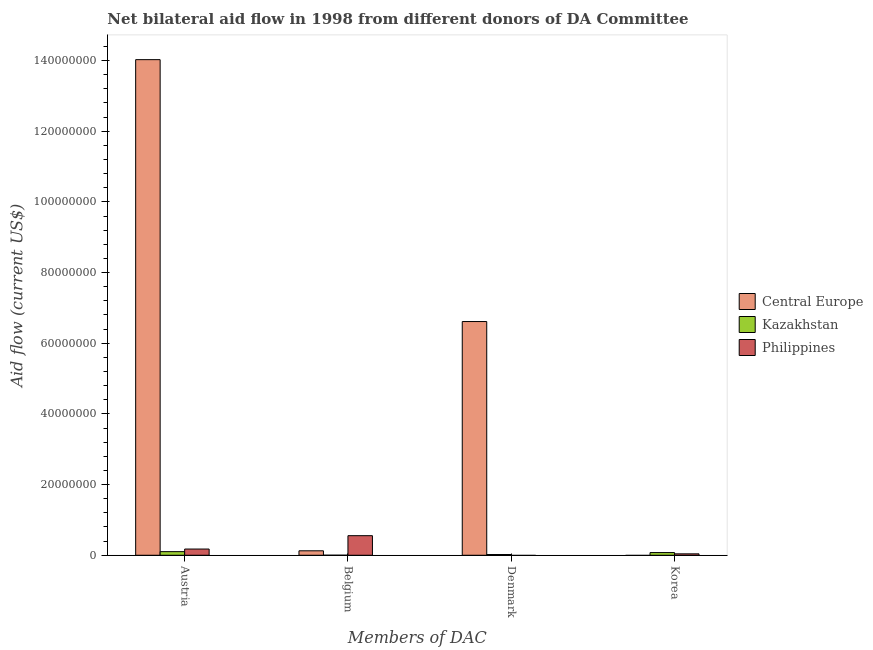How many different coloured bars are there?
Your answer should be compact. 3. How many bars are there on the 2nd tick from the left?
Offer a terse response. 3. How many bars are there on the 1st tick from the right?
Provide a succinct answer. 2. What is the label of the 4th group of bars from the left?
Your answer should be compact. Korea. What is the amount of aid given by austria in Kazakhstan?
Make the answer very short. 1.02e+06. Across all countries, what is the maximum amount of aid given by denmark?
Provide a succinct answer. 6.61e+07. Across all countries, what is the minimum amount of aid given by austria?
Make the answer very short. 1.02e+06. In which country was the amount of aid given by korea maximum?
Your answer should be very brief. Kazakhstan. What is the total amount of aid given by denmark in the graph?
Ensure brevity in your answer.  6.64e+07. What is the difference between the amount of aid given by belgium in Central Europe and that in Philippines?
Keep it short and to the point. -4.28e+06. What is the difference between the amount of aid given by denmark in Kazakhstan and the amount of aid given by austria in Central Europe?
Your answer should be very brief. -1.40e+08. What is the average amount of aid given by korea per country?
Offer a very short reply. 3.87e+05. What is the difference between the amount of aid given by austria and amount of aid given by belgium in Philippines?
Provide a succinct answer. -3.78e+06. What is the ratio of the amount of aid given by austria in Central Europe to that in Kazakhstan?
Give a very brief answer. 137.5. What is the difference between the highest and the second highest amount of aid given by belgium?
Offer a very short reply. 4.28e+06. What is the difference between the highest and the lowest amount of aid given by austria?
Your answer should be very brief. 1.39e+08. In how many countries, is the amount of aid given by austria greater than the average amount of aid given by austria taken over all countries?
Provide a succinct answer. 1. Is it the case that in every country, the sum of the amount of aid given by korea and amount of aid given by belgium is greater than the sum of amount of aid given by austria and amount of aid given by denmark?
Ensure brevity in your answer.  No. How many countries are there in the graph?
Your answer should be compact. 3. Does the graph contain grids?
Keep it short and to the point. No. How are the legend labels stacked?
Offer a very short reply. Vertical. What is the title of the graph?
Give a very brief answer. Net bilateral aid flow in 1998 from different donors of DA Committee. Does "China" appear as one of the legend labels in the graph?
Keep it short and to the point. No. What is the label or title of the X-axis?
Your answer should be compact. Members of DAC. What is the label or title of the Y-axis?
Your answer should be very brief. Aid flow (current US$). What is the Aid flow (current US$) of Central Europe in Austria?
Your response must be concise. 1.40e+08. What is the Aid flow (current US$) of Kazakhstan in Austria?
Provide a short and direct response. 1.02e+06. What is the Aid flow (current US$) in Philippines in Austria?
Your answer should be compact. 1.76e+06. What is the Aid flow (current US$) in Central Europe in Belgium?
Offer a very short reply. 1.26e+06. What is the Aid flow (current US$) of Philippines in Belgium?
Give a very brief answer. 5.54e+06. What is the Aid flow (current US$) of Central Europe in Denmark?
Give a very brief answer. 6.61e+07. What is the Aid flow (current US$) of Kazakhstan in Denmark?
Offer a terse response. 2.10e+05. What is the Aid flow (current US$) in Philippines in Denmark?
Your response must be concise. 0. What is the Aid flow (current US$) in Kazakhstan in Korea?
Offer a very short reply. 7.60e+05. Across all Members of DAC, what is the maximum Aid flow (current US$) of Central Europe?
Ensure brevity in your answer.  1.40e+08. Across all Members of DAC, what is the maximum Aid flow (current US$) of Kazakhstan?
Give a very brief answer. 1.02e+06. Across all Members of DAC, what is the maximum Aid flow (current US$) of Philippines?
Your response must be concise. 5.54e+06. Across all Members of DAC, what is the minimum Aid flow (current US$) of Central Europe?
Your answer should be compact. 0. What is the total Aid flow (current US$) of Central Europe in the graph?
Your answer should be very brief. 2.08e+08. What is the total Aid flow (current US$) of Philippines in the graph?
Make the answer very short. 7.70e+06. What is the difference between the Aid flow (current US$) of Central Europe in Austria and that in Belgium?
Offer a very short reply. 1.39e+08. What is the difference between the Aid flow (current US$) of Kazakhstan in Austria and that in Belgium?
Make the answer very short. 1.01e+06. What is the difference between the Aid flow (current US$) in Philippines in Austria and that in Belgium?
Provide a succinct answer. -3.78e+06. What is the difference between the Aid flow (current US$) of Central Europe in Austria and that in Denmark?
Give a very brief answer. 7.41e+07. What is the difference between the Aid flow (current US$) of Kazakhstan in Austria and that in Denmark?
Ensure brevity in your answer.  8.10e+05. What is the difference between the Aid flow (current US$) in Philippines in Austria and that in Korea?
Your answer should be compact. 1.36e+06. What is the difference between the Aid flow (current US$) in Central Europe in Belgium and that in Denmark?
Offer a very short reply. -6.49e+07. What is the difference between the Aid flow (current US$) of Kazakhstan in Belgium and that in Denmark?
Your response must be concise. -2.00e+05. What is the difference between the Aid flow (current US$) of Kazakhstan in Belgium and that in Korea?
Offer a terse response. -7.50e+05. What is the difference between the Aid flow (current US$) in Philippines in Belgium and that in Korea?
Provide a short and direct response. 5.14e+06. What is the difference between the Aid flow (current US$) of Kazakhstan in Denmark and that in Korea?
Your answer should be compact. -5.50e+05. What is the difference between the Aid flow (current US$) in Central Europe in Austria and the Aid flow (current US$) in Kazakhstan in Belgium?
Make the answer very short. 1.40e+08. What is the difference between the Aid flow (current US$) of Central Europe in Austria and the Aid flow (current US$) of Philippines in Belgium?
Offer a very short reply. 1.35e+08. What is the difference between the Aid flow (current US$) in Kazakhstan in Austria and the Aid flow (current US$) in Philippines in Belgium?
Your answer should be very brief. -4.52e+06. What is the difference between the Aid flow (current US$) of Central Europe in Austria and the Aid flow (current US$) of Kazakhstan in Denmark?
Make the answer very short. 1.40e+08. What is the difference between the Aid flow (current US$) in Central Europe in Austria and the Aid flow (current US$) in Kazakhstan in Korea?
Offer a terse response. 1.39e+08. What is the difference between the Aid flow (current US$) of Central Europe in Austria and the Aid flow (current US$) of Philippines in Korea?
Your answer should be very brief. 1.40e+08. What is the difference between the Aid flow (current US$) in Kazakhstan in Austria and the Aid flow (current US$) in Philippines in Korea?
Give a very brief answer. 6.20e+05. What is the difference between the Aid flow (current US$) in Central Europe in Belgium and the Aid flow (current US$) in Kazakhstan in Denmark?
Ensure brevity in your answer.  1.05e+06. What is the difference between the Aid flow (current US$) of Central Europe in Belgium and the Aid flow (current US$) of Kazakhstan in Korea?
Provide a succinct answer. 5.00e+05. What is the difference between the Aid flow (current US$) of Central Europe in Belgium and the Aid flow (current US$) of Philippines in Korea?
Give a very brief answer. 8.60e+05. What is the difference between the Aid flow (current US$) of Kazakhstan in Belgium and the Aid flow (current US$) of Philippines in Korea?
Make the answer very short. -3.90e+05. What is the difference between the Aid flow (current US$) of Central Europe in Denmark and the Aid flow (current US$) of Kazakhstan in Korea?
Provide a short and direct response. 6.54e+07. What is the difference between the Aid flow (current US$) of Central Europe in Denmark and the Aid flow (current US$) of Philippines in Korea?
Give a very brief answer. 6.57e+07. What is the average Aid flow (current US$) in Central Europe per Members of DAC?
Your answer should be compact. 5.19e+07. What is the average Aid flow (current US$) of Philippines per Members of DAC?
Make the answer very short. 1.92e+06. What is the difference between the Aid flow (current US$) of Central Europe and Aid flow (current US$) of Kazakhstan in Austria?
Make the answer very short. 1.39e+08. What is the difference between the Aid flow (current US$) of Central Europe and Aid flow (current US$) of Philippines in Austria?
Provide a short and direct response. 1.38e+08. What is the difference between the Aid flow (current US$) of Kazakhstan and Aid flow (current US$) of Philippines in Austria?
Make the answer very short. -7.40e+05. What is the difference between the Aid flow (current US$) of Central Europe and Aid flow (current US$) of Kazakhstan in Belgium?
Give a very brief answer. 1.25e+06. What is the difference between the Aid flow (current US$) in Central Europe and Aid flow (current US$) in Philippines in Belgium?
Ensure brevity in your answer.  -4.28e+06. What is the difference between the Aid flow (current US$) in Kazakhstan and Aid flow (current US$) in Philippines in Belgium?
Ensure brevity in your answer.  -5.53e+06. What is the difference between the Aid flow (current US$) in Central Europe and Aid flow (current US$) in Kazakhstan in Denmark?
Provide a succinct answer. 6.59e+07. What is the difference between the Aid flow (current US$) of Kazakhstan and Aid flow (current US$) of Philippines in Korea?
Your answer should be compact. 3.60e+05. What is the ratio of the Aid flow (current US$) in Central Europe in Austria to that in Belgium?
Your response must be concise. 111.31. What is the ratio of the Aid flow (current US$) in Kazakhstan in Austria to that in Belgium?
Provide a succinct answer. 102. What is the ratio of the Aid flow (current US$) in Philippines in Austria to that in Belgium?
Your response must be concise. 0.32. What is the ratio of the Aid flow (current US$) of Central Europe in Austria to that in Denmark?
Offer a terse response. 2.12. What is the ratio of the Aid flow (current US$) in Kazakhstan in Austria to that in Denmark?
Your answer should be compact. 4.86. What is the ratio of the Aid flow (current US$) in Kazakhstan in Austria to that in Korea?
Your answer should be compact. 1.34. What is the ratio of the Aid flow (current US$) in Philippines in Austria to that in Korea?
Provide a succinct answer. 4.4. What is the ratio of the Aid flow (current US$) of Central Europe in Belgium to that in Denmark?
Your answer should be compact. 0.02. What is the ratio of the Aid flow (current US$) in Kazakhstan in Belgium to that in Denmark?
Your response must be concise. 0.05. What is the ratio of the Aid flow (current US$) of Kazakhstan in Belgium to that in Korea?
Offer a terse response. 0.01. What is the ratio of the Aid flow (current US$) of Philippines in Belgium to that in Korea?
Offer a very short reply. 13.85. What is the ratio of the Aid flow (current US$) in Kazakhstan in Denmark to that in Korea?
Make the answer very short. 0.28. What is the difference between the highest and the second highest Aid flow (current US$) of Central Europe?
Your answer should be compact. 7.41e+07. What is the difference between the highest and the second highest Aid flow (current US$) of Philippines?
Your answer should be compact. 3.78e+06. What is the difference between the highest and the lowest Aid flow (current US$) in Central Europe?
Provide a succinct answer. 1.40e+08. What is the difference between the highest and the lowest Aid flow (current US$) in Kazakhstan?
Make the answer very short. 1.01e+06. What is the difference between the highest and the lowest Aid flow (current US$) in Philippines?
Make the answer very short. 5.54e+06. 